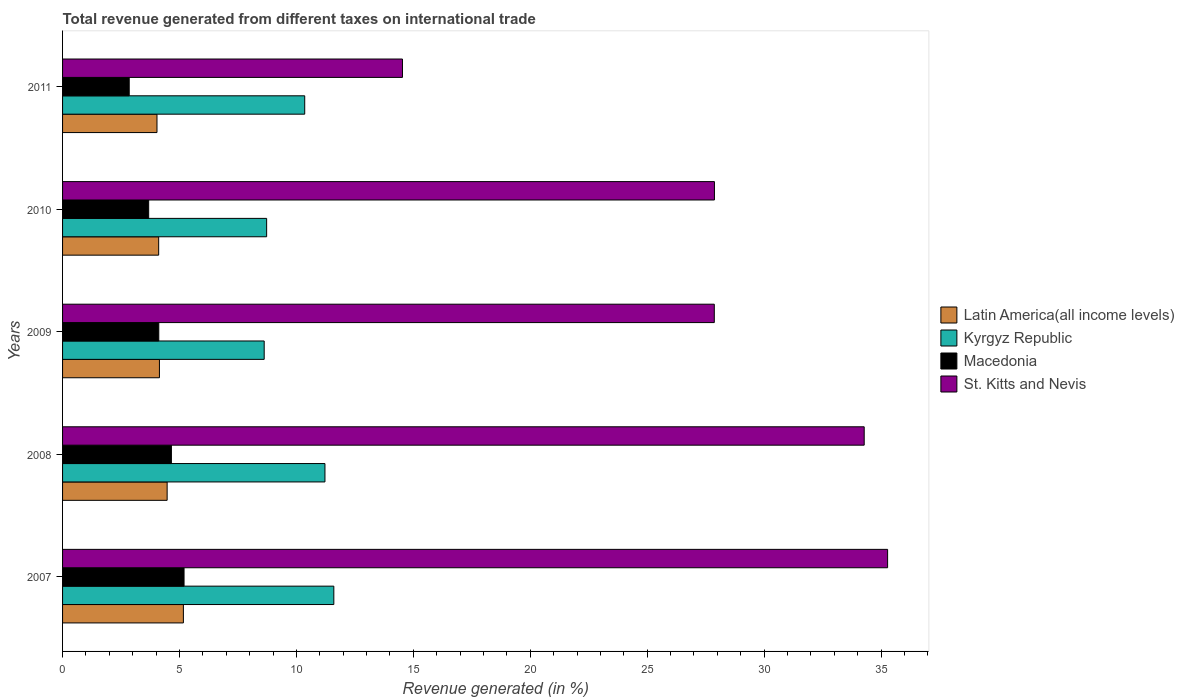How many groups of bars are there?
Ensure brevity in your answer.  5. Are the number of bars on each tick of the Y-axis equal?
Offer a very short reply. Yes. What is the label of the 3rd group of bars from the top?
Make the answer very short. 2009. What is the total revenue generated in Kyrgyz Republic in 2010?
Give a very brief answer. 8.73. Across all years, what is the maximum total revenue generated in St. Kitts and Nevis?
Your answer should be very brief. 35.28. Across all years, what is the minimum total revenue generated in St. Kitts and Nevis?
Provide a succinct answer. 14.53. In which year was the total revenue generated in Latin America(all income levels) maximum?
Ensure brevity in your answer.  2007. In which year was the total revenue generated in Kyrgyz Republic minimum?
Make the answer very short. 2009. What is the total total revenue generated in Kyrgyz Republic in the graph?
Your response must be concise. 50.52. What is the difference between the total revenue generated in St. Kitts and Nevis in 2009 and that in 2010?
Provide a short and direct response. -0.01. What is the difference between the total revenue generated in St. Kitts and Nevis in 2010 and the total revenue generated in Latin America(all income levels) in 2007?
Your answer should be very brief. 22.71. What is the average total revenue generated in Kyrgyz Republic per year?
Provide a short and direct response. 10.1. In the year 2009, what is the difference between the total revenue generated in Latin America(all income levels) and total revenue generated in Kyrgyz Republic?
Make the answer very short. -4.48. What is the ratio of the total revenue generated in St. Kitts and Nevis in 2008 to that in 2010?
Provide a succinct answer. 1.23. Is the difference between the total revenue generated in Latin America(all income levels) in 2009 and 2011 greater than the difference between the total revenue generated in Kyrgyz Republic in 2009 and 2011?
Make the answer very short. Yes. What is the difference between the highest and the second highest total revenue generated in Latin America(all income levels)?
Your answer should be compact. 0.69. What is the difference between the highest and the lowest total revenue generated in St. Kitts and Nevis?
Your answer should be compact. 20.75. In how many years, is the total revenue generated in Latin America(all income levels) greater than the average total revenue generated in Latin America(all income levels) taken over all years?
Keep it short and to the point. 2. Is the sum of the total revenue generated in Macedonia in 2008 and 2011 greater than the maximum total revenue generated in St. Kitts and Nevis across all years?
Make the answer very short. No. Is it the case that in every year, the sum of the total revenue generated in St. Kitts and Nevis and total revenue generated in Latin America(all income levels) is greater than the sum of total revenue generated in Kyrgyz Republic and total revenue generated in Macedonia?
Offer a very short reply. No. What does the 2nd bar from the top in 2008 represents?
Make the answer very short. Macedonia. What does the 4th bar from the bottom in 2009 represents?
Give a very brief answer. St. Kitts and Nevis. Is it the case that in every year, the sum of the total revenue generated in Macedonia and total revenue generated in Latin America(all income levels) is greater than the total revenue generated in Kyrgyz Republic?
Your response must be concise. No. How many bars are there?
Offer a terse response. 20. How many years are there in the graph?
Make the answer very short. 5. What is the difference between two consecutive major ticks on the X-axis?
Your response must be concise. 5. Does the graph contain grids?
Your answer should be compact. No. Where does the legend appear in the graph?
Make the answer very short. Center right. How many legend labels are there?
Provide a short and direct response. 4. How are the legend labels stacked?
Provide a short and direct response. Vertical. What is the title of the graph?
Make the answer very short. Total revenue generated from different taxes on international trade. What is the label or title of the X-axis?
Ensure brevity in your answer.  Revenue generated (in %). What is the label or title of the Y-axis?
Ensure brevity in your answer.  Years. What is the Revenue generated (in %) in Latin America(all income levels) in 2007?
Make the answer very short. 5.17. What is the Revenue generated (in %) in Kyrgyz Republic in 2007?
Provide a short and direct response. 11.6. What is the Revenue generated (in %) in Macedonia in 2007?
Your response must be concise. 5.19. What is the Revenue generated (in %) in St. Kitts and Nevis in 2007?
Ensure brevity in your answer.  35.28. What is the Revenue generated (in %) in Latin America(all income levels) in 2008?
Ensure brevity in your answer.  4.47. What is the Revenue generated (in %) of Kyrgyz Republic in 2008?
Offer a very short reply. 11.22. What is the Revenue generated (in %) in Macedonia in 2008?
Your answer should be very brief. 4.65. What is the Revenue generated (in %) of St. Kitts and Nevis in 2008?
Your answer should be compact. 34.28. What is the Revenue generated (in %) of Latin America(all income levels) in 2009?
Make the answer very short. 4.14. What is the Revenue generated (in %) of Kyrgyz Republic in 2009?
Your response must be concise. 8.62. What is the Revenue generated (in %) in Macedonia in 2009?
Provide a short and direct response. 4.11. What is the Revenue generated (in %) of St. Kitts and Nevis in 2009?
Give a very brief answer. 27.87. What is the Revenue generated (in %) of Latin America(all income levels) in 2010?
Offer a very short reply. 4.11. What is the Revenue generated (in %) in Kyrgyz Republic in 2010?
Make the answer very short. 8.73. What is the Revenue generated (in %) in Macedonia in 2010?
Your answer should be compact. 3.68. What is the Revenue generated (in %) of St. Kitts and Nevis in 2010?
Your response must be concise. 27.87. What is the Revenue generated (in %) in Latin America(all income levels) in 2011?
Ensure brevity in your answer.  4.04. What is the Revenue generated (in %) of Kyrgyz Republic in 2011?
Your response must be concise. 10.35. What is the Revenue generated (in %) of Macedonia in 2011?
Provide a succinct answer. 2.85. What is the Revenue generated (in %) of St. Kitts and Nevis in 2011?
Offer a very short reply. 14.53. Across all years, what is the maximum Revenue generated (in %) of Latin America(all income levels)?
Keep it short and to the point. 5.17. Across all years, what is the maximum Revenue generated (in %) in Kyrgyz Republic?
Give a very brief answer. 11.6. Across all years, what is the maximum Revenue generated (in %) of Macedonia?
Offer a very short reply. 5.19. Across all years, what is the maximum Revenue generated (in %) in St. Kitts and Nevis?
Offer a very short reply. 35.28. Across all years, what is the minimum Revenue generated (in %) of Latin America(all income levels)?
Offer a very short reply. 4.04. Across all years, what is the minimum Revenue generated (in %) of Kyrgyz Republic?
Your response must be concise. 8.62. Across all years, what is the minimum Revenue generated (in %) of Macedonia?
Provide a short and direct response. 2.85. Across all years, what is the minimum Revenue generated (in %) of St. Kitts and Nevis?
Offer a terse response. 14.53. What is the total Revenue generated (in %) of Latin America(all income levels) in the graph?
Offer a very short reply. 21.93. What is the total Revenue generated (in %) in Kyrgyz Republic in the graph?
Your answer should be compact. 50.52. What is the total Revenue generated (in %) of Macedonia in the graph?
Your answer should be compact. 20.5. What is the total Revenue generated (in %) in St. Kitts and Nevis in the graph?
Provide a succinct answer. 139.84. What is the difference between the Revenue generated (in %) of Latin America(all income levels) in 2007 and that in 2008?
Ensure brevity in your answer.  0.69. What is the difference between the Revenue generated (in %) of Kyrgyz Republic in 2007 and that in 2008?
Your answer should be compact. 0.38. What is the difference between the Revenue generated (in %) in Macedonia in 2007 and that in 2008?
Give a very brief answer. 0.54. What is the difference between the Revenue generated (in %) in Latin America(all income levels) in 2007 and that in 2009?
Ensure brevity in your answer.  1.02. What is the difference between the Revenue generated (in %) in Kyrgyz Republic in 2007 and that in 2009?
Provide a succinct answer. 2.98. What is the difference between the Revenue generated (in %) in Macedonia in 2007 and that in 2009?
Keep it short and to the point. 1.08. What is the difference between the Revenue generated (in %) in St. Kitts and Nevis in 2007 and that in 2009?
Your answer should be very brief. 7.41. What is the difference between the Revenue generated (in %) of Latin America(all income levels) in 2007 and that in 2010?
Offer a very short reply. 1.06. What is the difference between the Revenue generated (in %) of Kyrgyz Republic in 2007 and that in 2010?
Make the answer very short. 2.87. What is the difference between the Revenue generated (in %) in Macedonia in 2007 and that in 2010?
Your answer should be very brief. 1.51. What is the difference between the Revenue generated (in %) of St. Kitts and Nevis in 2007 and that in 2010?
Keep it short and to the point. 7.41. What is the difference between the Revenue generated (in %) of Latin America(all income levels) in 2007 and that in 2011?
Give a very brief answer. 1.13. What is the difference between the Revenue generated (in %) in Kyrgyz Republic in 2007 and that in 2011?
Make the answer very short. 1.24. What is the difference between the Revenue generated (in %) in Macedonia in 2007 and that in 2011?
Give a very brief answer. 2.35. What is the difference between the Revenue generated (in %) of St. Kitts and Nevis in 2007 and that in 2011?
Give a very brief answer. 20.75. What is the difference between the Revenue generated (in %) in Latin America(all income levels) in 2008 and that in 2009?
Your answer should be very brief. 0.33. What is the difference between the Revenue generated (in %) in Kyrgyz Republic in 2008 and that in 2009?
Provide a short and direct response. 2.6. What is the difference between the Revenue generated (in %) of Macedonia in 2008 and that in 2009?
Your response must be concise. 0.54. What is the difference between the Revenue generated (in %) in St. Kitts and Nevis in 2008 and that in 2009?
Make the answer very short. 6.41. What is the difference between the Revenue generated (in %) in Latin America(all income levels) in 2008 and that in 2010?
Offer a very short reply. 0.36. What is the difference between the Revenue generated (in %) in Kyrgyz Republic in 2008 and that in 2010?
Keep it short and to the point. 2.49. What is the difference between the Revenue generated (in %) in Macedonia in 2008 and that in 2010?
Provide a short and direct response. 0.97. What is the difference between the Revenue generated (in %) of St. Kitts and Nevis in 2008 and that in 2010?
Provide a short and direct response. 6.4. What is the difference between the Revenue generated (in %) of Latin America(all income levels) in 2008 and that in 2011?
Offer a very short reply. 0.43. What is the difference between the Revenue generated (in %) of Kyrgyz Republic in 2008 and that in 2011?
Provide a succinct answer. 0.87. What is the difference between the Revenue generated (in %) in Macedonia in 2008 and that in 2011?
Ensure brevity in your answer.  1.8. What is the difference between the Revenue generated (in %) of St. Kitts and Nevis in 2008 and that in 2011?
Provide a succinct answer. 19.74. What is the difference between the Revenue generated (in %) in Latin America(all income levels) in 2009 and that in 2010?
Your response must be concise. 0.03. What is the difference between the Revenue generated (in %) of Kyrgyz Republic in 2009 and that in 2010?
Provide a succinct answer. -0.1. What is the difference between the Revenue generated (in %) of Macedonia in 2009 and that in 2010?
Your answer should be compact. 0.43. What is the difference between the Revenue generated (in %) of St. Kitts and Nevis in 2009 and that in 2010?
Keep it short and to the point. -0.01. What is the difference between the Revenue generated (in %) of Latin America(all income levels) in 2009 and that in 2011?
Your answer should be compact. 0.11. What is the difference between the Revenue generated (in %) in Kyrgyz Republic in 2009 and that in 2011?
Make the answer very short. -1.73. What is the difference between the Revenue generated (in %) of Macedonia in 2009 and that in 2011?
Your answer should be very brief. 1.26. What is the difference between the Revenue generated (in %) in St. Kitts and Nevis in 2009 and that in 2011?
Offer a very short reply. 13.33. What is the difference between the Revenue generated (in %) in Latin America(all income levels) in 2010 and that in 2011?
Ensure brevity in your answer.  0.07. What is the difference between the Revenue generated (in %) in Kyrgyz Republic in 2010 and that in 2011?
Offer a very short reply. -1.63. What is the difference between the Revenue generated (in %) of Macedonia in 2010 and that in 2011?
Offer a terse response. 0.83. What is the difference between the Revenue generated (in %) in St. Kitts and Nevis in 2010 and that in 2011?
Your response must be concise. 13.34. What is the difference between the Revenue generated (in %) of Latin America(all income levels) in 2007 and the Revenue generated (in %) of Kyrgyz Republic in 2008?
Provide a short and direct response. -6.05. What is the difference between the Revenue generated (in %) of Latin America(all income levels) in 2007 and the Revenue generated (in %) of Macedonia in 2008?
Offer a terse response. 0.51. What is the difference between the Revenue generated (in %) in Latin America(all income levels) in 2007 and the Revenue generated (in %) in St. Kitts and Nevis in 2008?
Give a very brief answer. -29.11. What is the difference between the Revenue generated (in %) of Kyrgyz Republic in 2007 and the Revenue generated (in %) of Macedonia in 2008?
Your response must be concise. 6.95. What is the difference between the Revenue generated (in %) in Kyrgyz Republic in 2007 and the Revenue generated (in %) in St. Kitts and Nevis in 2008?
Keep it short and to the point. -22.68. What is the difference between the Revenue generated (in %) in Macedonia in 2007 and the Revenue generated (in %) in St. Kitts and Nevis in 2008?
Your answer should be very brief. -29.08. What is the difference between the Revenue generated (in %) in Latin America(all income levels) in 2007 and the Revenue generated (in %) in Kyrgyz Republic in 2009?
Your answer should be very brief. -3.46. What is the difference between the Revenue generated (in %) of Latin America(all income levels) in 2007 and the Revenue generated (in %) of Macedonia in 2009?
Offer a very short reply. 1.05. What is the difference between the Revenue generated (in %) in Latin America(all income levels) in 2007 and the Revenue generated (in %) in St. Kitts and Nevis in 2009?
Ensure brevity in your answer.  -22.7. What is the difference between the Revenue generated (in %) of Kyrgyz Republic in 2007 and the Revenue generated (in %) of Macedonia in 2009?
Offer a terse response. 7.48. What is the difference between the Revenue generated (in %) of Kyrgyz Republic in 2007 and the Revenue generated (in %) of St. Kitts and Nevis in 2009?
Your answer should be compact. -16.27. What is the difference between the Revenue generated (in %) of Macedonia in 2007 and the Revenue generated (in %) of St. Kitts and Nevis in 2009?
Ensure brevity in your answer.  -22.67. What is the difference between the Revenue generated (in %) of Latin America(all income levels) in 2007 and the Revenue generated (in %) of Kyrgyz Republic in 2010?
Offer a terse response. -3.56. What is the difference between the Revenue generated (in %) in Latin America(all income levels) in 2007 and the Revenue generated (in %) in Macedonia in 2010?
Offer a very short reply. 1.48. What is the difference between the Revenue generated (in %) of Latin America(all income levels) in 2007 and the Revenue generated (in %) of St. Kitts and Nevis in 2010?
Provide a short and direct response. -22.71. What is the difference between the Revenue generated (in %) of Kyrgyz Republic in 2007 and the Revenue generated (in %) of Macedonia in 2010?
Your answer should be compact. 7.92. What is the difference between the Revenue generated (in %) of Kyrgyz Republic in 2007 and the Revenue generated (in %) of St. Kitts and Nevis in 2010?
Keep it short and to the point. -16.28. What is the difference between the Revenue generated (in %) of Macedonia in 2007 and the Revenue generated (in %) of St. Kitts and Nevis in 2010?
Offer a terse response. -22.68. What is the difference between the Revenue generated (in %) of Latin America(all income levels) in 2007 and the Revenue generated (in %) of Kyrgyz Republic in 2011?
Provide a short and direct response. -5.19. What is the difference between the Revenue generated (in %) in Latin America(all income levels) in 2007 and the Revenue generated (in %) in Macedonia in 2011?
Offer a terse response. 2.32. What is the difference between the Revenue generated (in %) of Latin America(all income levels) in 2007 and the Revenue generated (in %) of St. Kitts and Nevis in 2011?
Provide a succinct answer. -9.37. What is the difference between the Revenue generated (in %) in Kyrgyz Republic in 2007 and the Revenue generated (in %) in Macedonia in 2011?
Offer a terse response. 8.75. What is the difference between the Revenue generated (in %) of Kyrgyz Republic in 2007 and the Revenue generated (in %) of St. Kitts and Nevis in 2011?
Keep it short and to the point. -2.94. What is the difference between the Revenue generated (in %) of Macedonia in 2007 and the Revenue generated (in %) of St. Kitts and Nevis in 2011?
Make the answer very short. -9.34. What is the difference between the Revenue generated (in %) of Latin America(all income levels) in 2008 and the Revenue generated (in %) of Kyrgyz Republic in 2009?
Offer a very short reply. -4.15. What is the difference between the Revenue generated (in %) of Latin America(all income levels) in 2008 and the Revenue generated (in %) of Macedonia in 2009?
Give a very brief answer. 0.36. What is the difference between the Revenue generated (in %) in Latin America(all income levels) in 2008 and the Revenue generated (in %) in St. Kitts and Nevis in 2009?
Offer a very short reply. -23.4. What is the difference between the Revenue generated (in %) in Kyrgyz Republic in 2008 and the Revenue generated (in %) in Macedonia in 2009?
Provide a succinct answer. 7.11. What is the difference between the Revenue generated (in %) in Kyrgyz Republic in 2008 and the Revenue generated (in %) in St. Kitts and Nevis in 2009?
Give a very brief answer. -16.65. What is the difference between the Revenue generated (in %) of Macedonia in 2008 and the Revenue generated (in %) of St. Kitts and Nevis in 2009?
Offer a terse response. -23.21. What is the difference between the Revenue generated (in %) in Latin America(all income levels) in 2008 and the Revenue generated (in %) in Kyrgyz Republic in 2010?
Your answer should be very brief. -4.25. What is the difference between the Revenue generated (in %) of Latin America(all income levels) in 2008 and the Revenue generated (in %) of Macedonia in 2010?
Offer a terse response. 0.79. What is the difference between the Revenue generated (in %) in Latin America(all income levels) in 2008 and the Revenue generated (in %) in St. Kitts and Nevis in 2010?
Keep it short and to the point. -23.4. What is the difference between the Revenue generated (in %) of Kyrgyz Republic in 2008 and the Revenue generated (in %) of Macedonia in 2010?
Provide a short and direct response. 7.54. What is the difference between the Revenue generated (in %) of Kyrgyz Republic in 2008 and the Revenue generated (in %) of St. Kitts and Nevis in 2010?
Give a very brief answer. -16.65. What is the difference between the Revenue generated (in %) in Macedonia in 2008 and the Revenue generated (in %) in St. Kitts and Nevis in 2010?
Your answer should be compact. -23.22. What is the difference between the Revenue generated (in %) of Latin America(all income levels) in 2008 and the Revenue generated (in %) of Kyrgyz Republic in 2011?
Provide a short and direct response. -5.88. What is the difference between the Revenue generated (in %) in Latin America(all income levels) in 2008 and the Revenue generated (in %) in Macedonia in 2011?
Your answer should be compact. 1.62. What is the difference between the Revenue generated (in %) in Latin America(all income levels) in 2008 and the Revenue generated (in %) in St. Kitts and Nevis in 2011?
Make the answer very short. -10.06. What is the difference between the Revenue generated (in %) of Kyrgyz Republic in 2008 and the Revenue generated (in %) of Macedonia in 2011?
Provide a succinct answer. 8.37. What is the difference between the Revenue generated (in %) in Kyrgyz Republic in 2008 and the Revenue generated (in %) in St. Kitts and Nevis in 2011?
Provide a succinct answer. -3.31. What is the difference between the Revenue generated (in %) in Macedonia in 2008 and the Revenue generated (in %) in St. Kitts and Nevis in 2011?
Your answer should be compact. -9.88. What is the difference between the Revenue generated (in %) of Latin America(all income levels) in 2009 and the Revenue generated (in %) of Kyrgyz Republic in 2010?
Keep it short and to the point. -4.58. What is the difference between the Revenue generated (in %) in Latin America(all income levels) in 2009 and the Revenue generated (in %) in Macedonia in 2010?
Your answer should be very brief. 0.46. What is the difference between the Revenue generated (in %) of Latin America(all income levels) in 2009 and the Revenue generated (in %) of St. Kitts and Nevis in 2010?
Your answer should be very brief. -23.73. What is the difference between the Revenue generated (in %) in Kyrgyz Republic in 2009 and the Revenue generated (in %) in Macedonia in 2010?
Ensure brevity in your answer.  4.94. What is the difference between the Revenue generated (in %) in Kyrgyz Republic in 2009 and the Revenue generated (in %) in St. Kitts and Nevis in 2010?
Ensure brevity in your answer.  -19.25. What is the difference between the Revenue generated (in %) of Macedonia in 2009 and the Revenue generated (in %) of St. Kitts and Nevis in 2010?
Offer a terse response. -23.76. What is the difference between the Revenue generated (in %) in Latin America(all income levels) in 2009 and the Revenue generated (in %) in Kyrgyz Republic in 2011?
Your answer should be very brief. -6.21. What is the difference between the Revenue generated (in %) in Latin America(all income levels) in 2009 and the Revenue generated (in %) in Macedonia in 2011?
Ensure brevity in your answer.  1.29. What is the difference between the Revenue generated (in %) in Latin America(all income levels) in 2009 and the Revenue generated (in %) in St. Kitts and Nevis in 2011?
Offer a terse response. -10.39. What is the difference between the Revenue generated (in %) of Kyrgyz Republic in 2009 and the Revenue generated (in %) of Macedonia in 2011?
Provide a succinct answer. 5.77. What is the difference between the Revenue generated (in %) of Kyrgyz Republic in 2009 and the Revenue generated (in %) of St. Kitts and Nevis in 2011?
Your answer should be compact. -5.91. What is the difference between the Revenue generated (in %) in Macedonia in 2009 and the Revenue generated (in %) in St. Kitts and Nevis in 2011?
Offer a very short reply. -10.42. What is the difference between the Revenue generated (in %) in Latin America(all income levels) in 2010 and the Revenue generated (in %) in Kyrgyz Republic in 2011?
Give a very brief answer. -6.24. What is the difference between the Revenue generated (in %) in Latin America(all income levels) in 2010 and the Revenue generated (in %) in Macedonia in 2011?
Your answer should be compact. 1.26. What is the difference between the Revenue generated (in %) in Latin America(all income levels) in 2010 and the Revenue generated (in %) in St. Kitts and Nevis in 2011?
Your answer should be compact. -10.42. What is the difference between the Revenue generated (in %) in Kyrgyz Republic in 2010 and the Revenue generated (in %) in Macedonia in 2011?
Your response must be concise. 5.88. What is the difference between the Revenue generated (in %) in Kyrgyz Republic in 2010 and the Revenue generated (in %) in St. Kitts and Nevis in 2011?
Provide a short and direct response. -5.81. What is the difference between the Revenue generated (in %) of Macedonia in 2010 and the Revenue generated (in %) of St. Kitts and Nevis in 2011?
Keep it short and to the point. -10.85. What is the average Revenue generated (in %) in Latin America(all income levels) per year?
Your answer should be compact. 4.39. What is the average Revenue generated (in %) of Kyrgyz Republic per year?
Make the answer very short. 10.1. What is the average Revenue generated (in %) in Macedonia per year?
Offer a terse response. 4.1. What is the average Revenue generated (in %) of St. Kitts and Nevis per year?
Give a very brief answer. 27.97. In the year 2007, what is the difference between the Revenue generated (in %) in Latin America(all income levels) and Revenue generated (in %) in Kyrgyz Republic?
Your response must be concise. -6.43. In the year 2007, what is the difference between the Revenue generated (in %) of Latin America(all income levels) and Revenue generated (in %) of Macedonia?
Your answer should be compact. -0.03. In the year 2007, what is the difference between the Revenue generated (in %) in Latin America(all income levels) and Revenue generated (in %) in St. Kitts and Nevis?
Offer a very short reply. -30.11. In the year 2007, what is the difference between the Revenue generated (in %) in Kyrgyz Republic and Revenue generated (in %) in Macedonia?
Offer a very short reply. 6.4. In the year 2007, what is the difference between the Revenue generated (in %) of Kyrgyz Republic and Revenue generated (in %) of St. Kitts and Nevis?
Your response must be concise. -23.68. In the year 2007, what is the difference between the Revenue generated (in %) of Macedonia and Revenue generated (in %) of St. Kitts and Nevis?
Provide a succinct answer. -30.09. In the year 2008, what is the difference between the Revenue generated (in %) of Latin America(all income levels) and Revenue generated (in %) of Kyrgyz Republic?
Offer a terse response. -6.75. In the year 2008, what is the difference between the Revenue generated (in %) of Latin America(all income levels) and Revenue generated (in %) of Macedonia?
Ensure brevity in your answer.  -0.18. In the year 2008, what is the difference between the Revenue generated (in %) of Latin America(all income levels) and Revenue generated (in %) of St. Kitts and Nevis?
Offer a terse response. -29.81. In the year 2008, what is the difference between the Revenue generated (in %) in Kyrgyz Republic and Revenue generated (in %) in Macedonia?
Ensure brevity in your answer.  6.57. In the year 2008, what is the difference between the Revenue generated (in %) of Kyrgyz Republic and Revenue generated (in %) of St. Kitts and Nevis?
Your answer should be very brief. -23.06. In the year 2008, what is the difference between the Revenue generated (in %) of Macedonia and Revenue generated (in %) of St. Kitts and Nevis?
Keep it short and to the point. -29.62. In the year 2009, what is the difference between the Revenue generated (in %) of Latin America(all income levels) and Revenue generated (in %) of Kyrgyz Republic?
Your response must be concise. -4.48. In the year 2009, what is the difference between the Revenue generated (in %) in Latin America(all income levels) and Revenue generated (in %) in Macedonia?
Offer a very short reply. 0.03. In the year 2009, what is the difference between the Revenue generated (in %) in Latin America(all income levels) and Revenue generated (in %) in St. Kitts and Nevis?
Keep it short and to the point. -23.73. In the year 2009, what is the difference between the Revenue generated (in %) of Kyrgyz Republic and Revenue generated (in %) of Macedonia?
Your response must be concise. 4.51. In the year 2009, what is the difference between the Revenue generated (in %) of Kyrgyz Republic and Revenue generated (in %) of St. Kitts and Nevis?
Provide a short and direct response. -19.25. In the year 2009, what is the difference between the Revenue generated (in %) of Macedonia and Revenue generated (in %) of St. Kitts and Nevis?
Your response must be concise. -23.75. In the year 2010, what is the difference between the Revenue generated (in %) in Latin America(all income levels) and Revenue generated (in %) in Kyrgyz Republic?
Your answer should be very brief. -4.62. In the year 2010, what is the difference between the Revenue generated (in %) in Latin America(all income levels) and Revenue generated (in %) in Macedonia?
Provide a short and direct response. 0.43. In the year 2010, what is the difference between the Revenue generated (in %) in Latin America(all income levels) and Revenue generated (in %) in St. Kitts and Nevis?
Offer a terse response. -23.76. In the year 2010, what is the difference between the Revenue generated (in %) in Kyrgyz Republic and Revenue generated (in %) in Macedonia?
Your answer should be compact. 5.04. In the year 2010, what is the difference between the Revenue generated (in %) in Kyrgyz Republic and Revenue generated (in %) in St. Kitts and Nevis?
Give a very brief answer. -19.15. In the year 2010, what is the difference between the Revenue generated (in %) in Macedonia and Revenue generated (in %) in St. Kitts and Nevis?
Your response must be concise. -24.19. In the year 2011, what is the difference between the Revenue generated (in %) of Latin America(all income levels) and Revenue generated (in %) of Kyrgyz Republic?
Offer a very short reply. -6.32. In the year 2011, what is the difference between the Revenue generated (in %) of Latin America(all income levels) and Revenue generated (in %) of Macedonia?
Give a very brief answer. 1.19. In the year 2011, what is the difference between the Revenue generated (in %) in Latin America(all income levels) and Revenue generated (in %) in St. Kitts and Nevis?
Your answer should be compact. -10.5. In the year 2011, what is the difference between the Revenue generated (in %) in Kyrgyz Republic and Revenue generated (in %) in Macedonia?
Keep it short and to the point. 7.5. In the year 2011, what is the difference between the Revenue generated (in %) of Kyrgyz Republic and Revenue generated (in %) of St. Kitts and Nevis?
Your answer should be very brief. -4.18. In the year 2011, what is the difference between the Revenue generated (in %) of Macedonia and Revenue generated (in %) of St. Kitts and Nevis?
Offer a very short reply. -11.68. What is the ratio of the Revenue generated (in %) in Latin America(all income levels) in 2007 to that in 2008?
Provide a succinct answer. 1.16. What is the ratio of the Revenue generated (in %) in Kyrgyz Republic in 2007 to that in 2008?
Your answer should be compact. 1.03. What is the ratio of the Revenue generated (in %) of Macedonia in 2007 to that in 2008?
Offer a very short reply. 1.12. What is the ratio of the Revenue generated (in %) in St. Kitts and Nevis in 2007 to that in 2008?
Offer a terse response. 1.03. What is the ratio of the Revenue generated (in %) of Latin America(all income levels) in 2007 to that in 2009?
Your answer should be compact. 1.25. What is the ratio of the Revenue generated (in %) in Kyrgyz Republic in 2007 to that in 2009?
Make the answer very short. 1.35. What is the ratio of the Revenue generated (in %) of Macedonia in 2007 to that in 2009?
Your answer should be compact. 1.26. What is the ratio of the Revenue generated (in %) in St. Kitts and Nevis in 2007 to that in 2009?
Give a very brief answer. 1.27. What is the ratio of the Revenue generated (in %) in Latin America(all income levels) in 2007 to that in 2010?
Keep it short and to the point. 1.26. What is the ratio of the Revenue generated (in %) of Kyrgyz Republic in 2007 to that in 2010?
Keep it short and to the point. 1.33. What is the ratio of the Revenue generated (in %) in Macedonia in 2007 to that in 2010?
Provide a succinct answer. 1.41. What is the ratio of the Revenue generated (in %) of St. Kitts and Nevis in 2007 to that in 2010?
Make the answer very short. 1.27. What is the ratio of the Revenue generated (in %) of Latin America(all income levels) in 2007 to that in 2011?
Make the answer very short. 1.28. What is the ratio of the Revenue generated (in %) in Kyrgyz Republic in 2007 to that in 2011?
Give a very brief answer. 1.12. What is the ratio of the Revenue generated (in %) of Macedonia in 2007 to that in 2011?
Ensure brevity in your answer.  1.82. What is the ratio of the Revenue generated (in %) in St. Kitts and Nevis in 2007 to that in 2011?
Your answer should be very brief. 2.43. What is the ratio of the Revenue generated (in %) of Latin America(all income levels) in 2008 to that in 2009?
Offer a very short reply. 1.08. What is the ratio of the Revenue generated (in %) of Kyrgyz Republic in 2008 to that in 2009?
Give a very brief answer. 1.3. What is the ratio of the Revenue generated (in %) of Macedonia in 2008 to that in 2009?
Offer a terse response. 1.13. What is the ratio of the Revenue generated (in %) in St. Kitts and Nevis in 2008 to that in 2009?
Your answer should be very brief. 1.23. What is the ratio of the Revenue generated (in %) of Latin America(all income levels) in 2008 to that in 2010?
Offer a terse response. 1.09. What is the ratio of the Revenue generated (in %) in Kyrgyz Republic in 2008 to that in 2010?
Offer a terse response. 1.29. What is the ratio of the Revenue generated (in %) in Macedonia in 2008 to that in 2010?
Give a very brief answer. 1.26. What is the ratio of the Revenue generated (in %) of St. Kitts and Nevis in 2008 to that in 2010?
Make the answer very short. 1.23. What is the ratio of the Revenue generated (in %) in Latin America(all income levels) in 2008 to that in 2011?
Your response must be concise. 1.11. What is the ratio of the Revenue generated (in %) of Kyrgyz Republic in 2008 to that in 2011?
Provide a succinct answer. 1.08. What is the ratio of the Revenue generated (in %) of Macedonia in 2008 to that in 2011?
Give a very brief answer. 1.63. What is the ratio of the Revenue generated (in %) of St. Kitts and Nevis in 2008 to that in 2011?
Your answer should be very brief. 2.36. What is the ratio of the Revenue generated (in %) in Latin America(all income levels) in 2009 to that in 2010?
Your response must be concise. 1.01. What is the ratio of the Revenue generated (in %) in Kyrgyz Republic in 2009 to that in 2010?
Give a very brief answer. 0.99. What is the ratio of the Revenue generated (in %) in Macedonia in 2009 to that in 2010?
Provide a succinct answer. 1.12. What is the ratio of the Revenue generated (in %) of St. Kitts and Nevis in 2009 to that in 2010?
Keep it short and to the point. 1. What is the ratio of the Revenue generated (in %) of Latin America(all income levels) in 2009 to that in 2011?
Your answer should be very brief. 1.03. What is the ratio of the Revenue generated (in %) in Kyrgyz Republic in 2009 to that in 2011?
Your answer should be very brief. 0.83. What is the ratio of the Revenue generated (in %) of Macedonia in 2009 to that in 2011?
Make the answer very short. 1.44. What is the ratio of the Revenue generated (in %) of St. Kitts and Nevis in 2009 to that in 2011?
Your response must be concise. 1.92. What is the ratio of the Revenue generated (in %) of Latin America(all income levels) in 2010 to that in 2011?
Your answer should be very brief. 1.02. What is the ratio of the Revenue generated (in %) of Kyrgyz Republic in 2010 to that in 2011?
Ensure brevity in your answer.  0.84. What is the ratio of the Revenue generated (in %) in Macedonia in 2010 to that in 2011?
Your answer should be very brief. 1.29. What is the ratio of the Revenue generated (in %) in St. Kitts and Nevis in 2010 to that in 2011?
Offer a very short reply. 1.92. What is the difference between the highest and the second highest Revenue generated (in %) of Latin America(all income levels)?
Keep it short and to the point. 0.69. What is the difference between the highest and the second highest Revenue generated (in %) of Kyrgyz Republic?
Provide a succinct answer. 0.38. What is the difference between the highest and the second highest Revenue generated (in %) in Macedonia?
Your response must be concise. 0.54. What is the difference between the highest and the lowest Revenue generated (in %) in Latin America(all income levels)?
Provide a succinct answer. 1.13. What is the difference between the highest and the lowest Revenue generated (in %) in Kyrgyz Republic?
Provide a succinct answer. 2.98. What is the difference between the highest and the lowest Revenue generated (in %) in Macedonia?
Your answer should be very brief. 2.35. What is the difference between the highest and the lowest Revenue generated (in %) in St. Kitts and Nevis?
Make the answer very short. 20.75. 